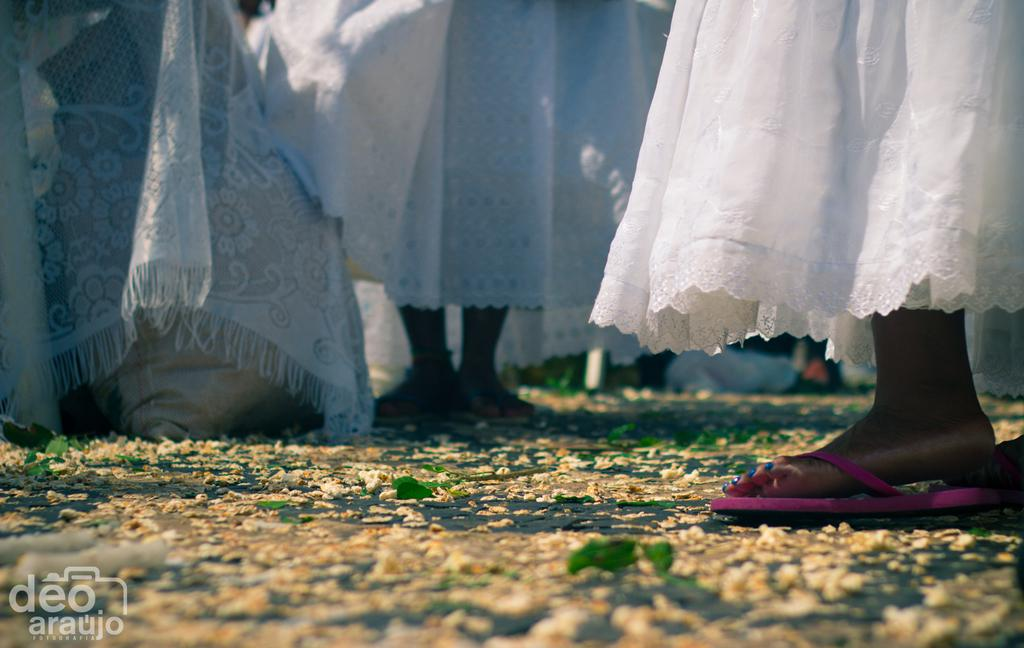What is the main subject of the image? The main subject of the image is a group of people. What are the people wearing in the image? The people are wearing white dresses in the image. What are the people doing in the image? The people are standing in the image. What can be seen on the road in the image? There are flowers on the road in the image. Where is the text located in the image? The text is at the bottom left of the image. What type of basin is visible in the image? There is no basin present in the image. Can you tell me how many boots are being worn by the people in the image? The people in the image are wearing white dresses, not boots, so it is not possible to determine the number of boots being worn. 